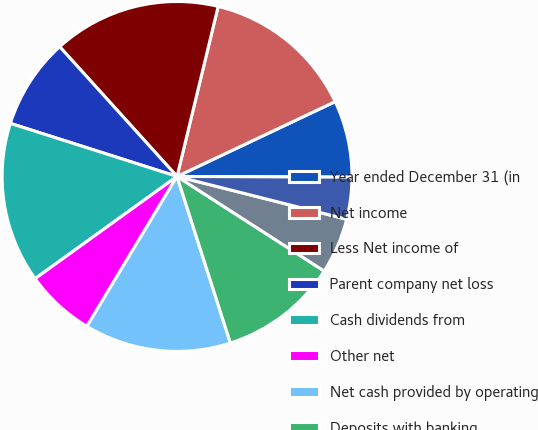<chart> <loc_0><loc_0><loc_500><loc_500><pie_chart><fcel>Year ended December 31 (in<fcel>Net income<fcel>Less Net income of<fcel>Parent company net loss<fcel>Cash dividends from<fcel>Other net<fcel>Net cash provided by operating<fcel>Deposits with banking<fcel>Purchases<fcel>Proceeds from sales and<nl><fcel>7.1%<fcel>14.19%<fcel>15.48%<fcel>8.39%<fcel>14.84%<fcel>6.45%<fcel>13.55%<fcel>10.97%<fcel>5.16%<fcel>3.87%<nl></chart> 